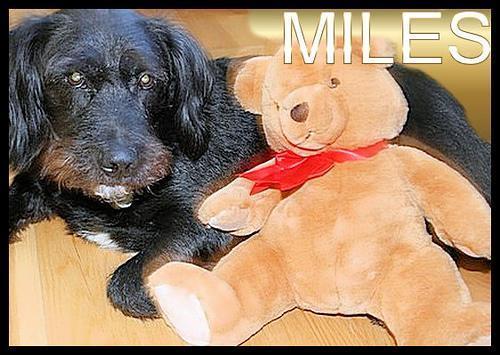How many live creatures are in the picture?
Give a very brief answer. 1. How many dogs are in the photo?
Give a very brief answer. 1. 